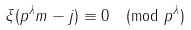Convert formula to latex. <formula><loc_0><loc_0><loc_500><loc_500>\xi ( p ^ { \lambda } m - j ) \equiv 0 \pmod { p ^ { \lambda } }</formula> 